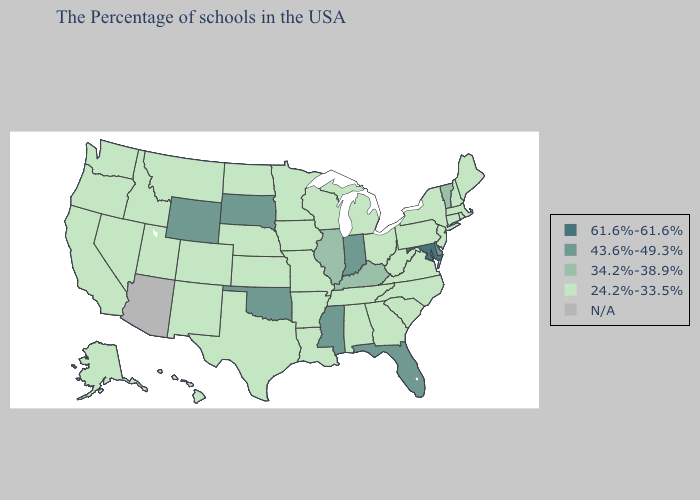Is the legend a continuous bar?
Quick response, please. No. Name the states that have a value in the range 61.6%-61.6%?
Keep it brief. Maryland. Name the states that have a value in the range 34.2%-38.9%?
Short answer required. Vermont, Kentucky, Illinois. Name the states that have a value in the range N/A?
Be succinct. Arizona. Name the states that have a value in the range 61.6%-61.6%?
Concise answer only. Maryland. What is the value of Maryland?
Short answer required. 61.6%-61.6%. What is the lowest value in the South?
Answer briefly. 24.2%-33.5%. What is the value of Kansas?
Answer briefly. 24.2%-33.5%. Name the states that have a value in the range 43.6%-49.3%?
Answer briefly. Delaware, Florida, Indiana, Mississippi, Oklahoma, South Dakota, Wyoming. Name the states that have a value in the range 61.6%-61.6%?
Short answer required. Maryland. Name the states that have a value in the range 61.6%-61.6%?
Write a very short answer. Maryland. How many symbols are there in the legend?
Give a very brief answer. 5. Name the states that have a value in the range 24.2%-33.5%?
Answer briefly. Maine, Massachusetts, Rhode Island, New Hampshire, Connecticut, New York, New Jersey, Pennsylvania, Virginia, North Carolina, South Carolina, West Virginia, Ohio, Georgia, Michigan, Alabama, Tennessee, Wisconsin, Louisiana, Missouri, Arkansas, Minnesota, Iowa, Kansas, Nebraska, Texas, North Dakota, Colorado, New Mexico, Utah, Montana, Idaho, Nevada, California, Washington, Oregon, Alaska, Hawaii. 